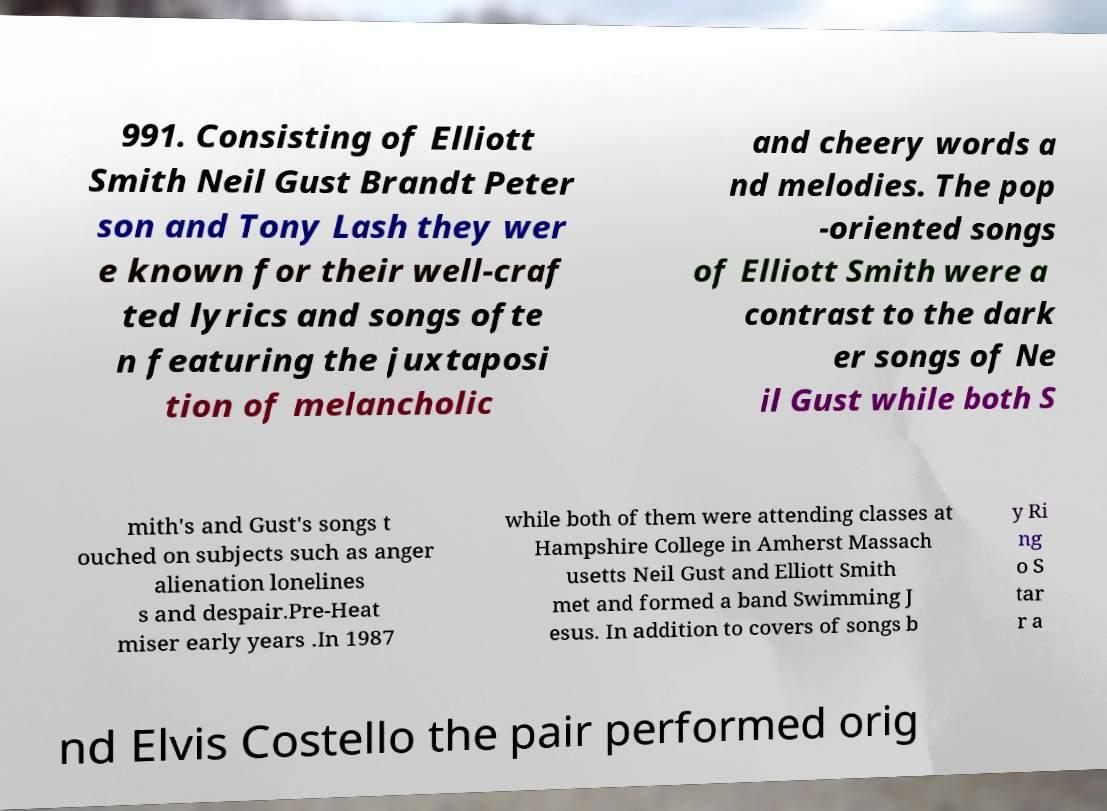Could you assist in decoding the text presented in this image and type it out clearly? 991. Consisting of Elliott Smith Neil Gust Brandt Peter son and Tony Lash they wer e known for their well-craf ted lyrics and songs ofte n featuring the juxtaposi tion of melancholic and cheery words a nd melodies. The pop -oriented songs of Elliott Smith were a contrast to the dark er songs of Ne il Gust while both S mith's and Gust's songs t ouched on subjects such as anger alienation lonelines s and despair.Pre-Heat miser early years .In 1987 while both of them were attending classes at Hampshire College in Amherst Massach usetts Neil Gust and Elliott Smith met and formed a band Swimming J esus. In addition to covers of songs b y Ri ng o S tar r a nd Elvis Costello the pair performed orig 